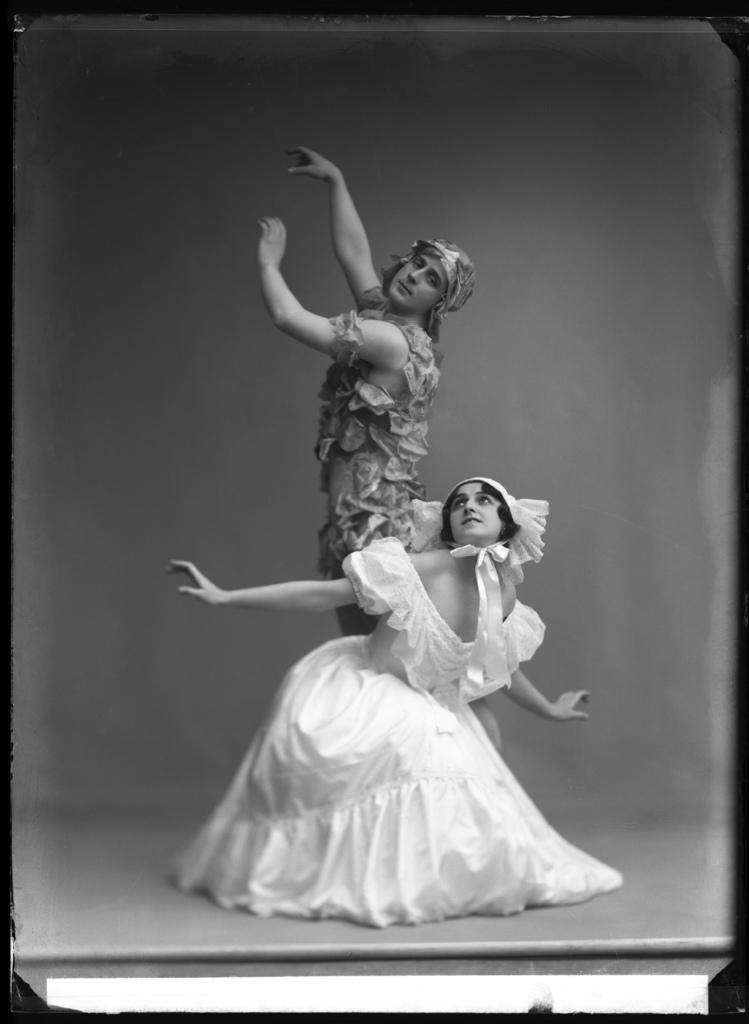How many people are in the image? There are two people in the image, a man and a woman. What are the man and the woman wearing? Both the man and the woman are wearing costumes. What is the color scheme of the image? The image is black and white. What type of furniture can be seen in the image? There is no furniture present in the image; it features a man and a woman wearing costumes. How do the man and the woman say good-bye in the image? There is no indication of the man and the woman saying good-bye in the image. 